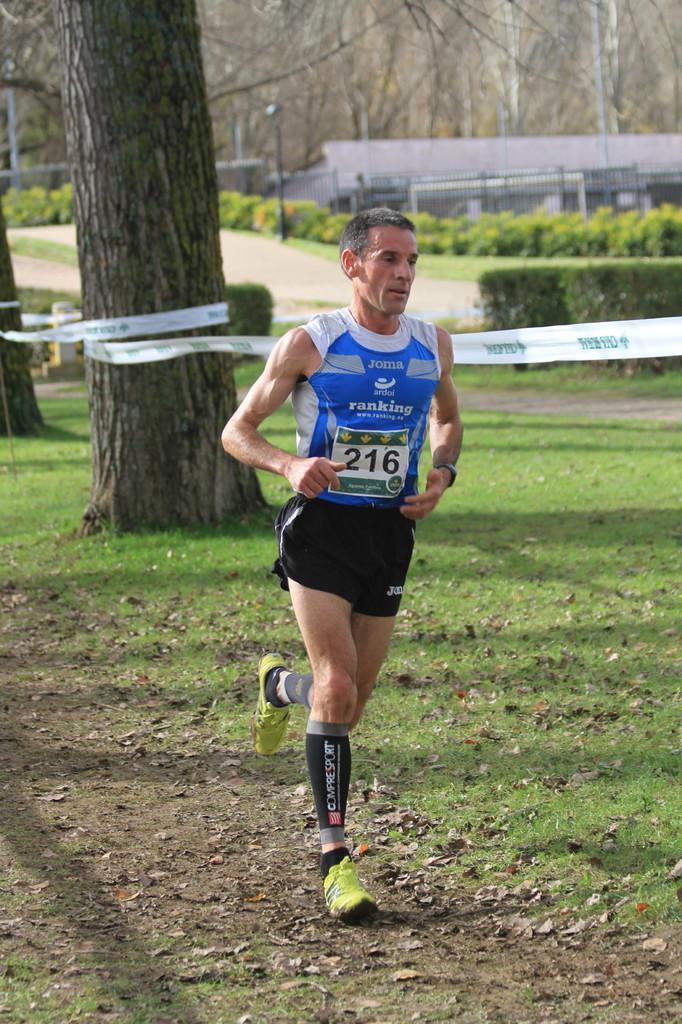Describe this image in one or two sentences. This image is taken outdoors. At the bottom of the image there is a ground with grass on it. In the background there are a few trees and plants on the ground. In the middle of the image a man is running on the ground. 